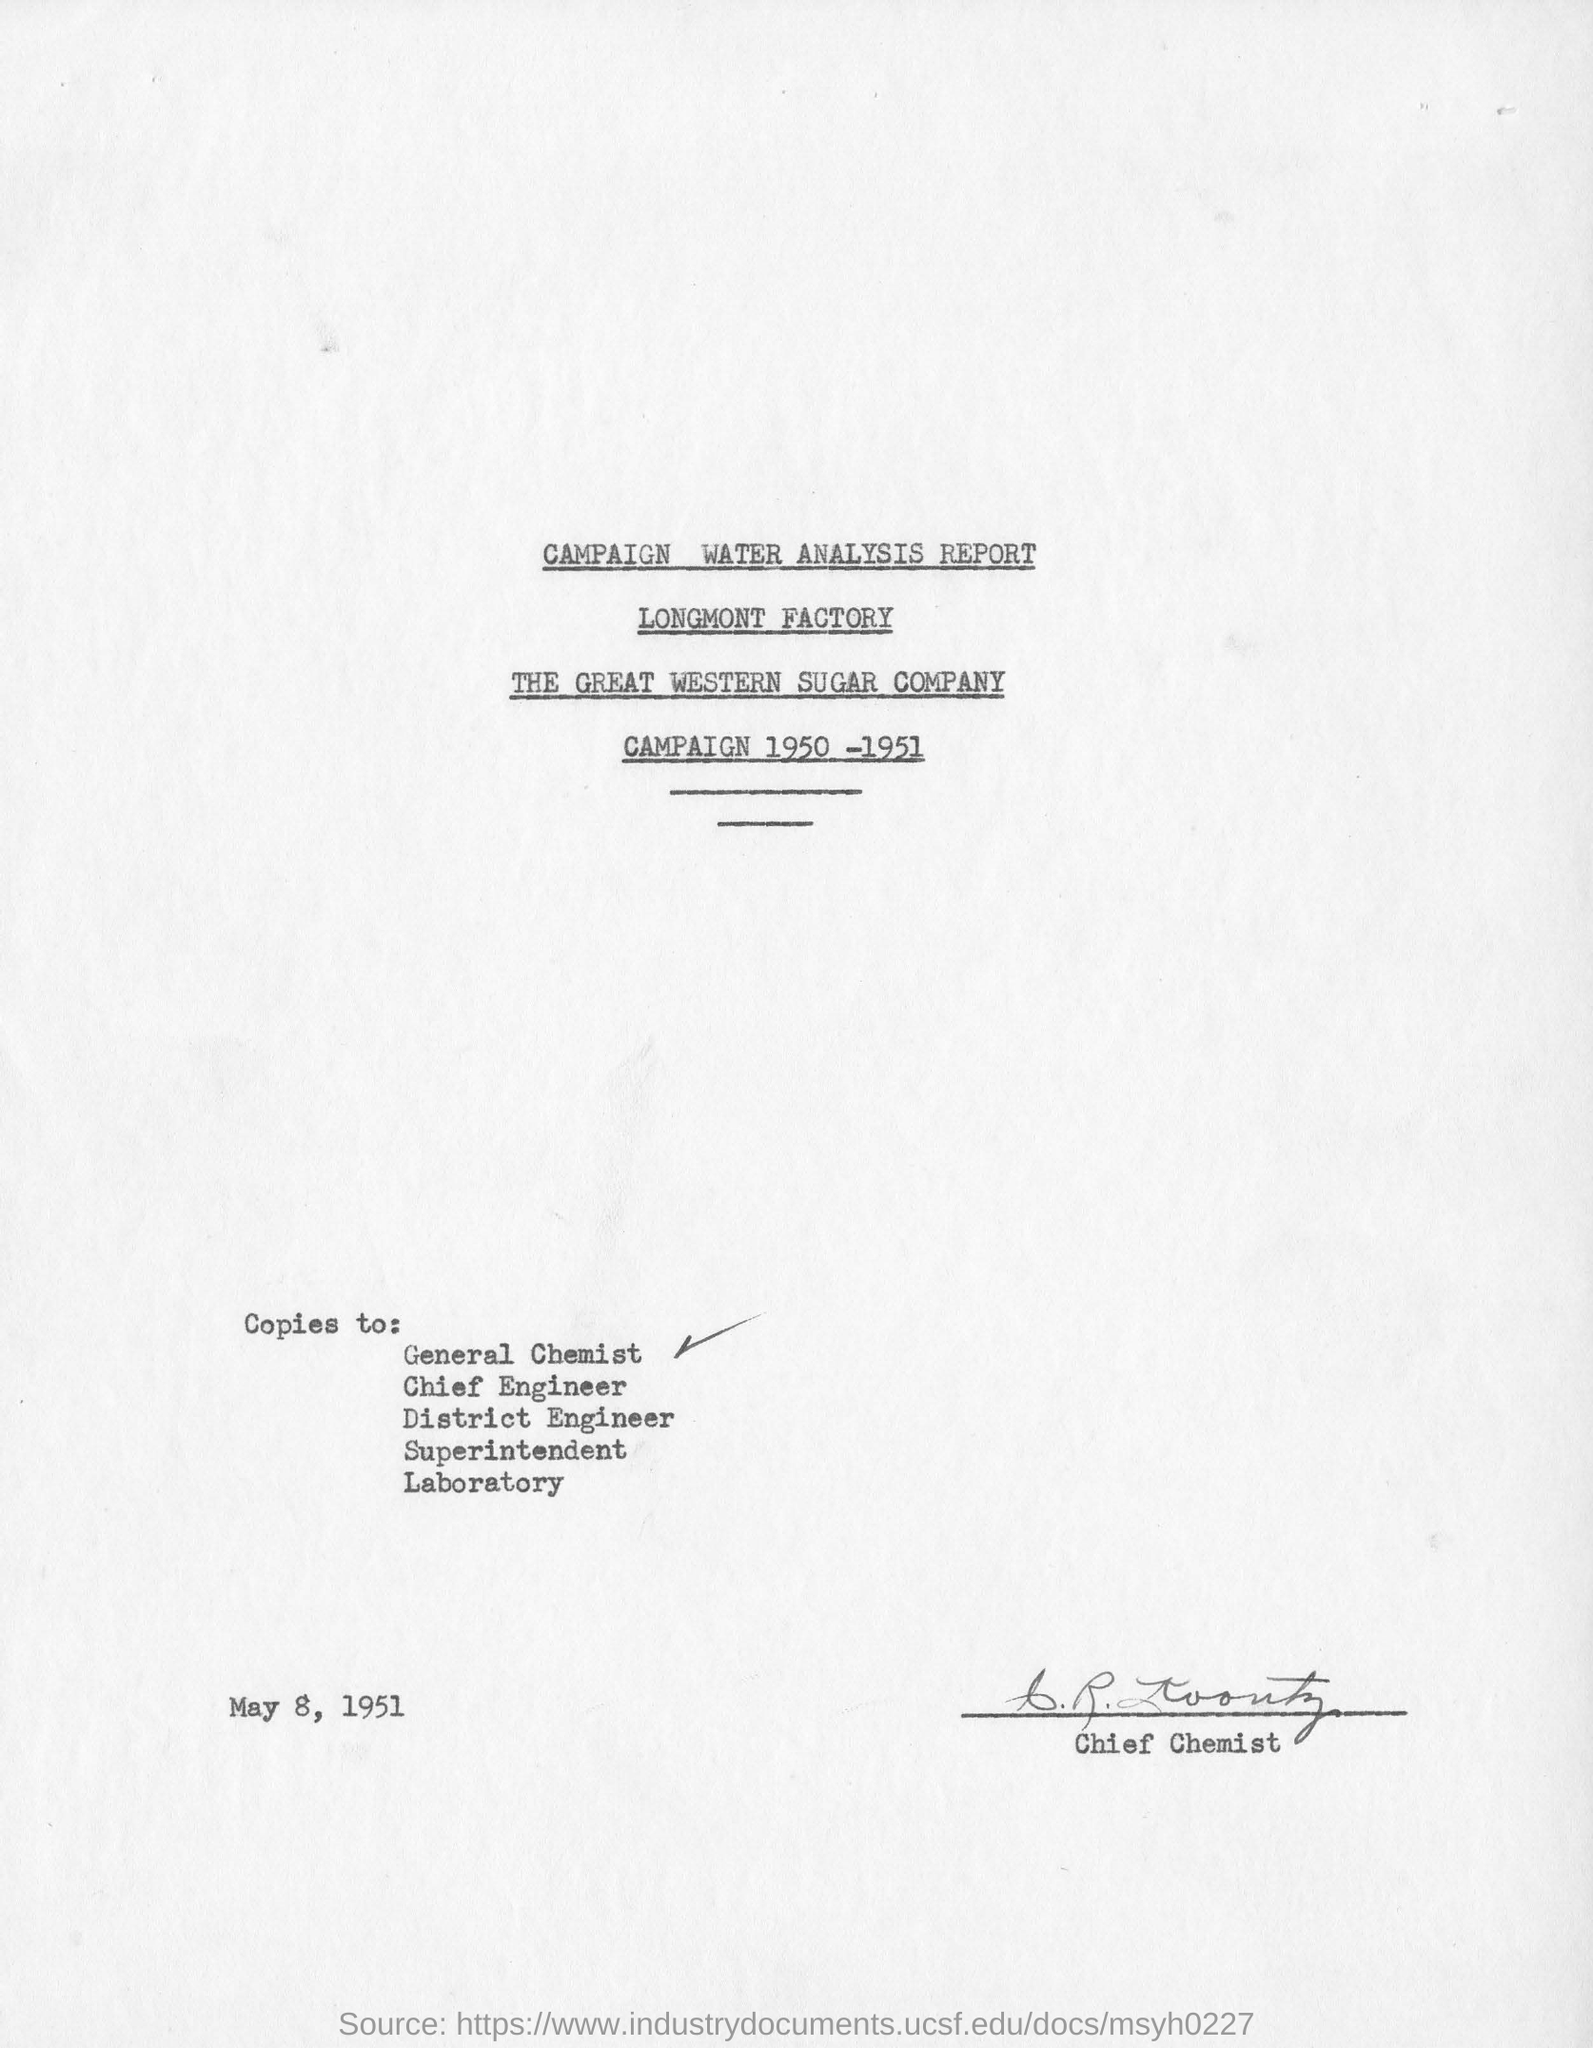Outline some significant characteristics in this image. The date mentioned in the report is May 8, 1951. 